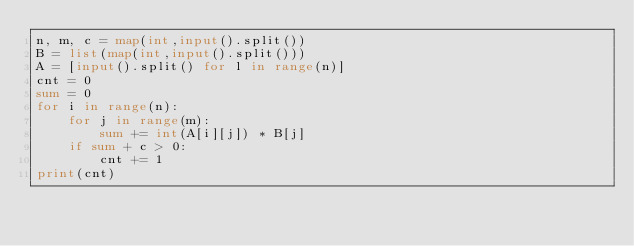<code> <loc_0><loc_0><loc_500><loc_500><_Python_>n, m, c = map(int,input().split())
B = list(map(int,input().split()))
A = [input().split() for l in range(n)]
cnt = 0
sum = 0
for i in range(n):
    for j in range(m):
        sum += int(A[i][j]) * B[j]
    if sum + c > 0:
        cnt += 1
print(cnt)
</code> 